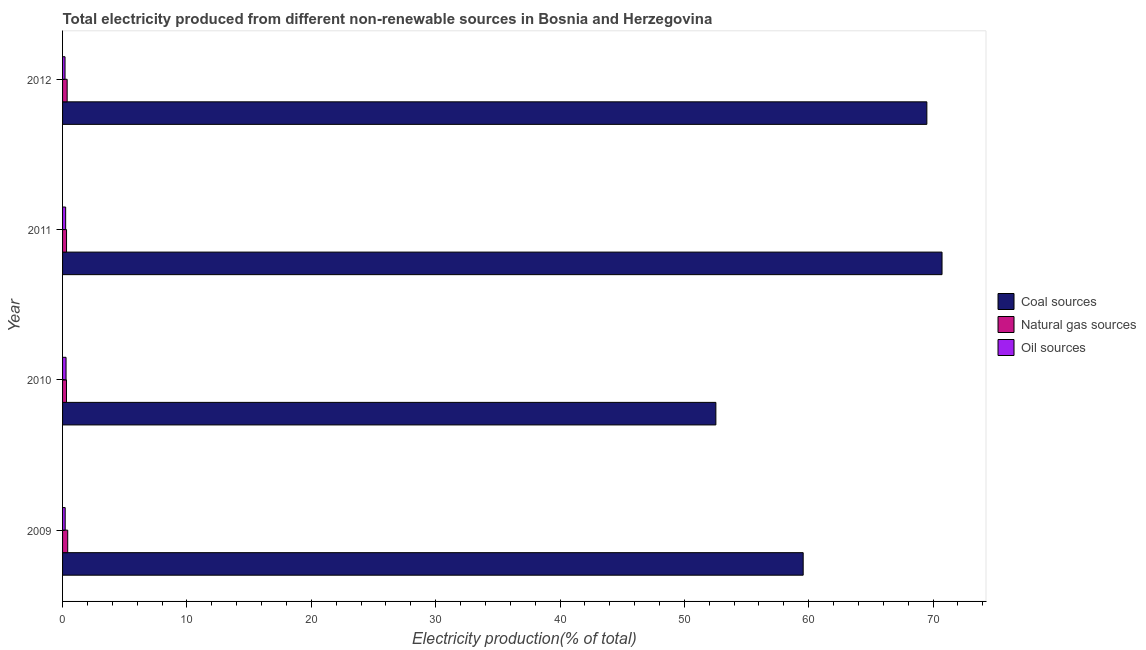How many different coloured bars are there?
Make the answer very short. 3. Are the number of bars per tick equal to the number of legend labels?
Provide a succinct answer. Yes. Are the number of bars on each tick of the Y-axis equal?
Offer a very short reply. Yes. How many bars are there on the 2nd tick from the bottom?
Ensure brevity in your answer.  3. In how many cases, is the number of bars for a given year not equal to the number of legend labels?
Make the answer very short. 0. What is the percentage of electricity produced by oil sources in 2011?
Keep it short and to the point. 0.25. Across all years, what is the maximum percentage of electricity produced by natural gas?
Your answer should be compact. 0.41. Across all years, what is the minimum percentage of electricity produced by natural gas?
Provide a short and direct response. 0.32. In which year was the percentage of electricity produced by coal maximum?
Your answer should be compact. 2011. In which year was the percentage of electricity produced by natural gas minimum?
Provide a short and direct response. 2010. What is the total percentage of electricity produced by coal in the graph?
Make the answer very short. 252.31. What is the difference between the percentage of electricity produced by coal in 2009 and that in 2011?
Provide a succinct answer. -11.16. What is the difference between the percentage of electricity produced by natural gas in 2009 and the percentage of electricity produced by coal in 2012?
Your answer should be compact. -69.09. What is the average percentage of electricity produced by natural gas per year?
Provide a short and direct response. 0.35. In the year 2009, what is the difference between the percentage of electricity produced by natural gas and percentage of electricity produced by oil sources?
Provide a succinct answer. 0.2. What is the ratio of the percentage of electricity produced by natural gas in 2011 to that in 2012?
Your answer should be very brief. 0.87. Is the difference between the percentage of electricity produced by oil sources in 2009 and 2010 greater than the difference between the percentage of electricity produced by coal in 2009 and 2010?
Ensure brevity in your answer.  No. What is the difference between the highest and the second highest percentage of electricity produced by oil sources?
Offer a very short reply. 0.03. What is the difference between the highest and the lowest percentage of electricity produced by oil sources?
Your answer should be compact. 0.08. What does the 1st bar from the top in 2011 represents?
Provide a short and direct response. Oil sources. What does the 2nd bar from the bottom in 2011 represents?
Your answer should be very brief. Natural gas sources. How many bars are there?
Your answer should be compact. 12. How many years are there in the graph?
Keep it short and to the point. 4. What is the difference between two consecutive major ticks on the X-axis?
Give a very brief answer. 10. Are the values on the major ticks of X-axis written in scientific E-notation?
Give a very brief answer. No. How many legend labels are there?
Offer a very short reply. 3. How are the legend labels stacked?
Offer a terse response. Vertical. What is the title of the graph?
Offer a very short reply. Total electricity produced from different non-renewable sources in Bosnia and Herzegovina. What is the Electricity production(% of total) of Coal sources in 2009?
Your answer should be very brief. 59.55. What is the Electricity production(% of total) of Natural gas sources in 2009?
Your response must be concise. 0.41. What is the Electricity production(% of total) of Oil sources in 2009?
Provide a succinct answer. 0.21. What is the Electricity production(% of total) in Coal sources in 2010?
Ensure brevity in your answer.  52.53. What is the Electricity production(% of total) of Natural gas sources in 2010?
Offer a very short reply. 0.32. What is the Electricity production(% of total) of Oil sources in 2010?
Offer a very short reply. 0.28. What is the Electricity production(% of total) of Coal sources in 2011?
Offer a very short reply. 70.72. What is the Electricity production(% of total) in Natural gas sources in 2011?
Provide a succinct answer. 0.32. What is the Electricity production(% of total) of Oil sources in 2011?
Provide a succinct answer. 0.25. What is the Electricity production(% of total) in Coal sources in 2012?
Give a very brief answer. 69.5. What is the Electricity production(% of total) of Natural gas sources in 2012?
Ensure brevity in your answer.  0.37. What is the Electricity production(% of total) in Oil sources in 2012?
Your response must be concise. 0.2. Across all years, what is the maximum Electricity production(% of total) in Coal sources?
Your response must be concise. 70.72. Across all years, what is the maximum Electricity production(% of total) of Natural gas sources?
Give a very brief answer. 0.41. Across all years, what is the maximum Electricity production(% of total) in Oil sources?
Keep it short and to the point. 0.28. Across all years, what is the minimum Electricity production(% of total) in Coal sources?
Give a very brief answer. 52.53. Across all years, what is the minimum Electricity production(% of total) in Natural gas sources?
Give a very brief answer. 0.32. Across all years, what is the minimum Electricity production(% of total) in Oil sources?
Your answer should be compact. 0.2. What is the total Electricity production(% of total) in Coal sources in the graph?
Offer a terse response. 252.31. What is the total Electricity production(% of total) of Natural gas sources in the graph?
Your response must be concise. 1.42. What is the total Electricity production(% of total) in Oil sources in the graph?
Provide a short and direct response. 0.94. What is the difference between the Electricity production(% of total) in Coal sources in 2009 and that in 2010?
Your response must be concise. 7.02. What is the difference between the Electricity production(% of total) in Natural gas sources in 2009 and that in 2010?
Your response must be concise. 0.1. What is the difference between the Electricity production(% of total) in Oil sources in 2009 and that in 2010?
Make the answer very short. -0.07. What is the difference between the Electricity production(% of total) of Coal sources in 2009 and that in 2011?
Your answer should be compact. -11.17. What is the difference between the Electricity production(% of total) of Natural gas sources in 2009 and that in 2011?
Keep it short and to the point. 0.09. What is the difference between the Electricity production(% of total) in Oil sources in 2009 and that in 2011?
Your answer should be very brief. -0.04. What is the difference between the Electricity production(% of total) in Coal sources in 2009 and that in 2012?
Provide a succinct answer. -9.95. What is the difference between the Electricity production(% of total) of Natural gas sources in 2009 and that in 2012?
Give a very brief answer. 0.05. What is the difference between the Electricity production(% of total) in Oil sources in 2009 and that in 2012?
Offer a terse response. 0.01. What is the difference between the Electricity production(% of total) of Coal sources in 2010 and that in 2011?
Give a very brief answer. -18.19. What is the difference between the Electricity production(% of total) in Natural gas sources in 2010 and that in 2011?
Offer a very short reply. -0.01. What is the difference between the Electricity production(% of total) in Oil sources in 2010 and that in 2011?
Ensure brevity in your answer.  0.03. What is the difference between the Electricity production(% of total) in Coal sources in 2010 and that in 2012?
Provide a short and direct response. -16.97. What is the difference between the Electricity production(% of total) of Natural gas sources in 2010 and that in 2012?
Keep it short and to the point. -0.05. What is the difference between the Electricity production(% of total) of Oil sources in 2010 and that in 2012?
Ensure brevity in your answer.  0.08. What is the difference between the Electricity production(% of total) of Coal sources in 2011 and that in 2012?
Your response must be concise. 1.22. What is the difference between the Electricity production(% of total) in Natural gas sources in 2011 and that in 2012?
Make the answer very short. -0.05. What is the difference between the Electricity production(% of total) in Oil sources in 2011 and that in 2012?
Keep it short and to the point. 0.05. What is the difference between the Electricity production(% of total) in Coal sources in 2009 and the Electricity production(% of total) in Natural gas sources in 2010?
Your answer should be compact. 59.24. What is the difference between the Electricity production(% of total) in Coal sources in 2009 and the Electricity production(% of total) in Oil sources in 2010?
Offer a very short reply. 59.27. What is the difference between the Electricity production(% of total) in Natural gas sources in 2009 and the Electricity production(% of total) in Oil sources in 2010?
Offer a terse response. 0.13. What is the difference between the Electricity production(% of total) of Coal sources in 2009 and the Electricity production(% of total) of Natural gas sources in 2011?
Make the answer very short. 59.23. What is the difference between the Electricity production(% of total) of Coal sources in 2009 and the Electricity production(% of total) of Oil sources in 2011?
Your answer should be compact. 59.31. What is the difference between the Electricity production(% of total) of Natural gas sources in 2009 and the Electricity production(% of total) of Oil sources in 2011?
Make the answer very short. 0.17. What is the difference between the Electricity production(% of total) in Coal sources in 2009 and the Electricity production(% of total) in Natural gas sources in 2012?
Your response must be concise. 59.19. What is the difference between the Electricity production(% of total) of Coal sources in 2009 and the Electricity production(% of total) of Oil sources in 2012?
Provide a succinct answer. 59.36. What is the difference between the Electricity production(% of total) in Natural gas sources in 2009 and the Electricity production(% of total) in Oil sources in 2012?
Offer a terse response. 0.22. What is the difference between the Electricity production(% of total) in Coal sources in 2010 and the Electricity production(% of total) in Natural gas sources in 2011?
Your answer should be compact. 52.21. What is the difference between the Electricity production(% of total) of Coal sources in 2010 and the Electricity production(% of total) of Oil sources in 2011?
Your answer should be compact. 52.29. What is the difference between the Electricity production(% of total) of Natural gas sources in 2010 and the Electricity production(% of total) of Oil sources in 2011?
Give a very brief answer. 0.07. What is the difference between the Electricity production(% of total) of Coal sources in 2010 and the Electricity production(% of total) of Natural gas sources in 2012?
Your answer should be very brief. 52.17. What is the difference between the Electricity production(% of total) of Coal sources in 2010 and the Electricity production(% of total) of Oil sources in 2012?
Your response must be concise. 52.34. What is the difference between the Electricity production(% of total) in Natural gas sources in 2010 and the Electricity production(% of total) in Oil sources in 2012?
Give a very brief answer. 0.12. What is the difference between the Electricity production(% of total) in Coal sources in 2011 and the Electricity production(% of total) in Natural gas sources in 2012?
Offer a terse response. 70.35. What is the difference between the Electricity production(% of total) in Coal sources in 2011 and the Electricity production(% of total) in Oil sources in 2012?
Give a very brief answer. 70.52. What is the difference between the Electricity production(% of total) of Natural gas sources in 2011 and the Electricity production(% of total) of Oil sources in 2012?
Ensure brevity in your answer.  0.12. What is the average Electricity production(% of total) of Coal sources per year?
Provide a short and direct response. 63.08. What is the average Electricity production(% of total) of Natural gas sources per year?
Your answer should be compact. 0.35. What is the average Electricity production(% of total) of Oil sources per year?
Your answer should be very brief. 0.23. In the year 2009, what is the difference between the Electricity production(% of total) of Coal sources and Electricity production(% of total) of Natural gas sources?
Your answer should be compact. 59.14. In the year 2009, what is the difference between the Electricity production(% of total) of Coal sources and Electricity production(% of total) of Oil sources?
Your response must be concise. 59.34. In the year 2009, what is the difference between the Electricity production(% of total) of Natural gas sources and Electricity production(% of total) of Oil sources?
Your answer should be very brief. 0.2. In the year 2010, what is the difference between the Electricity production(% of total) in Coal sources and Electricity production(% of total) in Natural gas sources?
Provide a succinct answer. 52.22. In the year 2010, what is the difference between the Electricity production(% of total) of Coal sources and Electricity production(% of total) of Oil sources?
Provide a short and direct response. 52.25. In the year 2010, what is the difference between the Electricity production(% of total) of Natural gas sources and Electricity production(% of total) of Oil sources?
Make the answer very short. 0.04. In the year 2011, what is the difference between the Electricity production(% of total) in Coal sources and Electricity production(% of total) in Natural gas sources?
Offer a very short reply. 70.4. In the year 2011, what is the difference between the Electricity production(% of total) in Coal sources and Electricity production(% of total) in Oil sources?
Offer a very short reply. 70.47. In the year 2011, what is the difference between the Electricity production(% of total) of Natural gas sources and Electricity production(% of total) of Oil sources?
Provide a succinct answer. 0.07. In the year 2012, what is the difference between the Electricity production(% of total) in Coal sources and Electricity production(% of total) in Natural gas sources?
Ensure brevity in your answer.  69.13. In the year 2012, what is the difference between the Electricity production(% of total) in Coal sources and Electricity production(% of total) in Oil sources?
Provide a succinct answer. 69.3. In the year 2012, what is the difference between the Electricity production(% of total) of Natural gas sources and Electricity production(% of total) of Oil sources?
Keep it short and to the point. 0.17. What is the ratio of the Electricity production(% of total) in Coal sources in 2009 to that in 2010?
Provide a short and direct response. 1.13. What is the ratio of the Electricity production(% of total) of Natural gas sources in 2009 to that in 2010?
Your answer should be compact. 1.32. What is the ratio of the Electricity production(% of total) of Oil sources in 2009 to that in 2010?
Give a very brief answer. 0.75. What is the ratio of the Electricity production(% of total) in Coal sources in 2009 to that in 2011?
Your answer should be very brief. 0.84. What is the ratio of the Electricity production(% of total) in Natural gas sources in 2009 to that in 2011?
Offer a terse response. 1.29. What is the ratio of the Electricity production(% of total) in Oil sources in 2009 to that in 2011?
Give a very brief answer. 0.85. What is the ratio of the Electricity production(% of total) in Coal sources in 2009 to that in 2012?
Your answer should be compact. 0.86. What is the ratio of the Electricity production(% of total) in Natural gas sources in 2009 to that in 2012?
Your answer should be compact. 1.12. What is the ratio of the Electricity production(% of total) in Oil sources in 2009 to that in 2012?
Give a very brief answer. 1.06. What is the ratio of the Electricity production(% of total) of Coal sources in 2010 to that in 2011?
Offer a very short reply. 0.74. What is the ratio of the Electricity production(% of total) in Natural gas sources in 2010 to that in 2011?
Provide a succinct answer. 0.98. What is the ratio of the Electricity production(% of total) of Oil sources in 2010 to that in 2011?
Offer a terse response. 1.13. What is the ratio of the Electricity production(% of total) in Coal sources in 2010 to that in 2012?
Give a very brief answer. 0.76. What is the ratio of the Electricity production(% of total) in Natural gas sources in 2010 to that in 2012?
Offer a terse response. 0.85. What is the ratio of the Electricity production(% of total) in Oil sources in 2010 to that in 2012?
Your response must be concise. 1.41. What is the ratio of the Electricity production(% of total) of Coal sources in 2011 to that in 2012?
Your answer should be very brief. 1.02. What is the ratio of the Electricity production(% of total) of Natural gas sources in 2011 to that in 2012?
Provide a short and direct response. 0.87. What is the ratio of the Electricity production(% of total) in Oil sources in 2011 to that in 2012?
Give a very brief answer. 1.25. What is the difference between the highest and the second highest Electricity production(% of total) in Coal sources?
Offer a very short reply. 1.22. What is the difference between the highest and the second highest Electricity production(% of total) in Natural gas sources?
Provide a succinct answer. 0.05. What is the difference between the highest and the second highest Electricity production(% of total) of Oil sources?
Your answer should be very brief. 0.03. What is the difference between the highest and the lowest Electricity production(% of total) of Coal sources?
Offer a terse response. 18.19. What is the difference between the highest and the lowest Electricity production(% of total) in Natural gas sources?
Provide a short and direct response. 0.1. What is the difference between the highest and the lowest Electricity production(% of total) in Oil sources?
Offer a terse response. 0.08. 